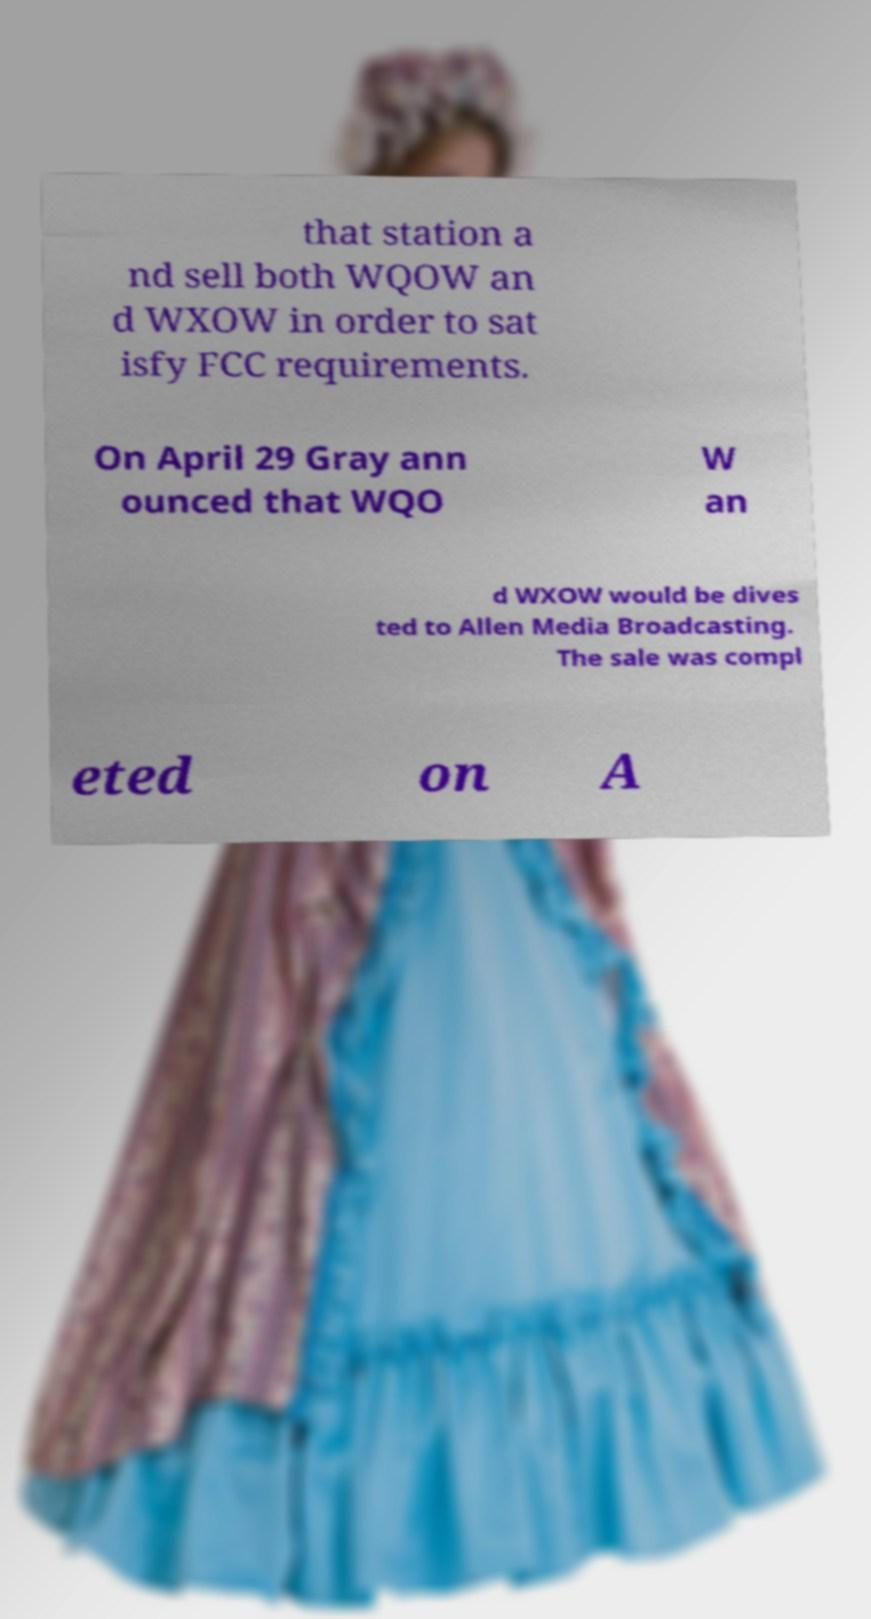Please identify and transcribe the text found in this image. that station a nd sell both WQOW an d WXOW in order to sat isfy FCC requirements. On April 29 Gray ann ounced that WQO W an d WXOW would be dives ted to Allen Media Broadcasting. The sale was compl eted on A 